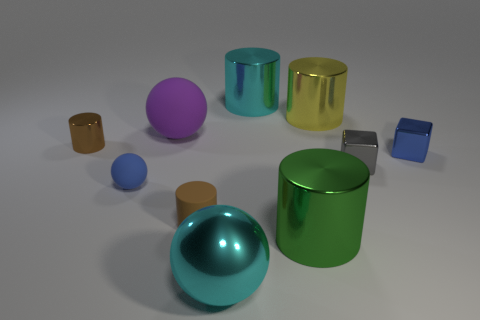Subtract all green cylinders. How many cylinders are left? 4 Subtract 2 cylinders. How many cylinders are left? 3 Subtract all big green cylinders. How many cylinders are left? 4 Subtract all cyan cylinders. Subtract all cyan spheres. How many cylinders are left? 4 Subtract all balls. How many objects are left? 7 Subtract all big yellow metal cylinders. Subtract all small spheres. How many objects are left? 8 Add 5 small blue cubes. How many small blue cubes are left? 6 Add 4 brown metal cylinders. How many brown metal cylinders exist? 5 Subtract 0 green blocks. How many objects are left? 10 